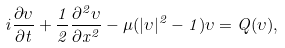<formula> <loc_0><loc_0><loc_500><loc_500>i \frac { \partial \upsilon } { \partial t } + \frac { 1 } { 2 } \frac { \partial ^ { 2 } \upsilon } { \partial x ^ { 2 } } - \mu ( | \upsilon | ^ { 2 } - 1 ) \upsilon = Q ( \upsilon ) ,</formula> 